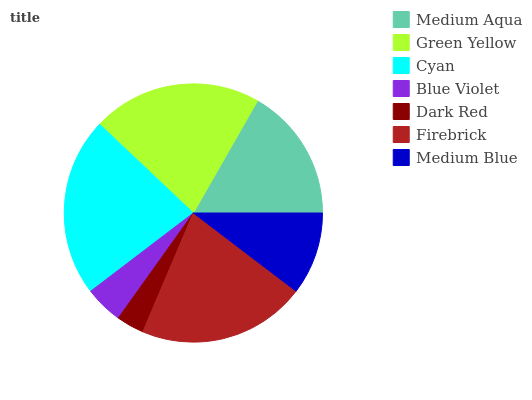Is Dark Red the minimum?
Answer yes or no. Yes. Is Cyan the maximum?
Answer yes or no. Yes. Is Green Yellow the minimum?
Answer yes or no. No. Is Green Yellow the maximum?
Answer yes or no. No. Is Green Yellow greater than Medium Aqua?
Answer yes or no. Yes. Is Medium Aqua less than Green Yellow?
Answer yes or no. Yes. Is Medium Aqua greater than Green Yellow?
Answer yes or no. No. Is Green Yellow less than Medium Aqua?
Answer yes or no. No. Is Medium Aqua the high median?
Answer yes or no. Yes. Is Medium Aqua the low median?
Answer yes or no. Yes. Is Dark Red the high median?
Answer yes or no. No. Is Firebrick the low median?
Answer yes or no. No. 